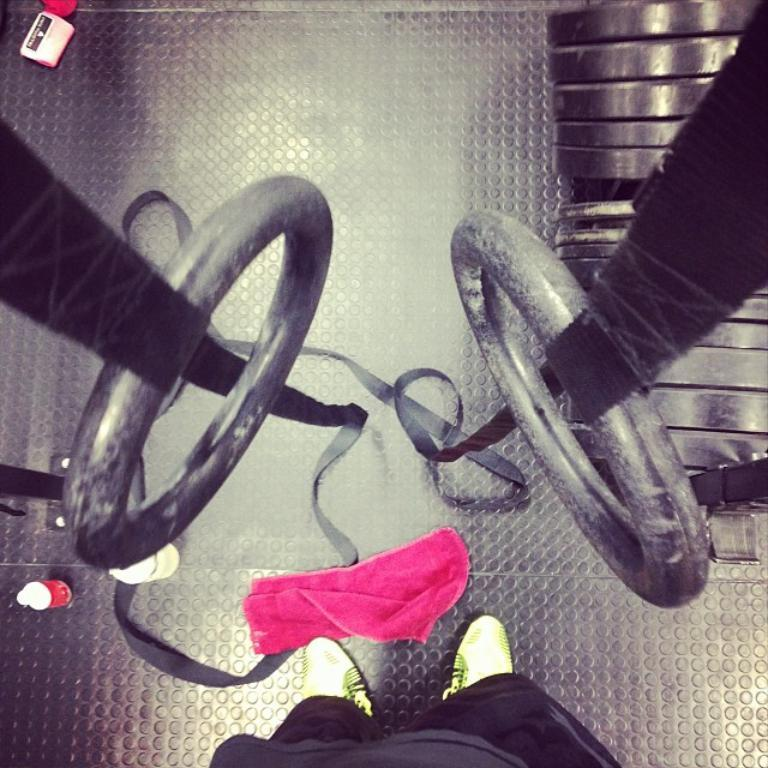What is the main object in the center of the image? There are pull up rings in the center of the image. Can you describe the person in the image? There is a person at the bottom of the image. What is the condition of the floor in the image? There is a napkin on the floor. What type of event is taking place in the image? There is no indication of an event taking place in the image. Can you tell me where the faucet is located in the image? There is no faucet present in the image. 